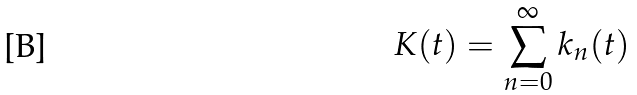Convert formula to latex. <formula><loc_0><loc_0><loc_500><loc_500>K ( t ) = \sum _ { n = 0 } ^ { \infty } k _ { n } ( t )</formula> 